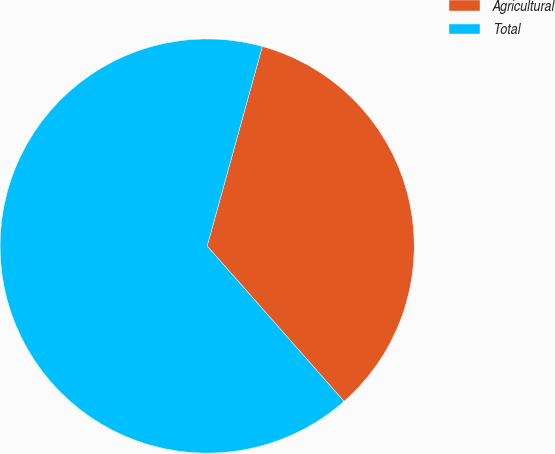<chart> <loc_0><loc_0><loc_500><loc_500><pie_chart><fcel>Agricultural<fcel>Total<nl><fcel>34.21%<fcel>65.79%<nl></chart> 